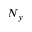Convert formula to latex. <formula><loc_0><loc_0><loc_500><loc_500>N _ { y }</formula> 